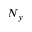Convert formula to latex. <formula><loc_0><loc_0><loc_500><loc_500>N _ { y }</formula> 